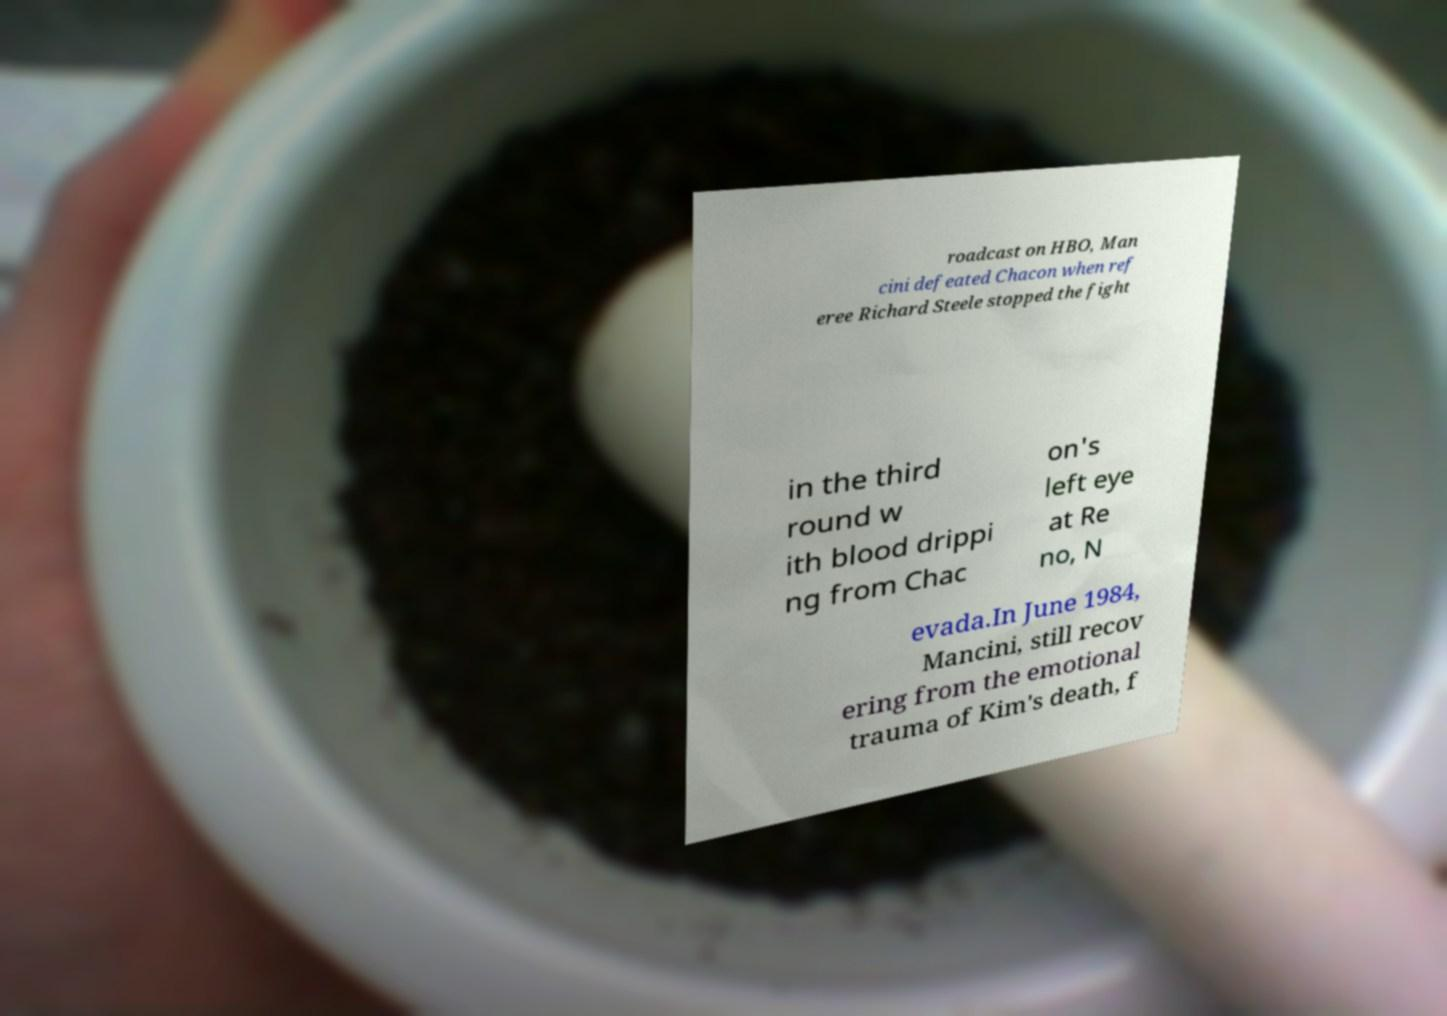Could you assist in decoding the text presented in this image and type it out clearly? roadcast on HBO, Man cini defeated Chacon when ref eree Richard Steele stopped the fight in the third round w ith blood drippi ng from Chac on's left eye at Re no, N evada.In June 1984, Mancini, still recov ering from the emotional trauma of Kim's death, f 